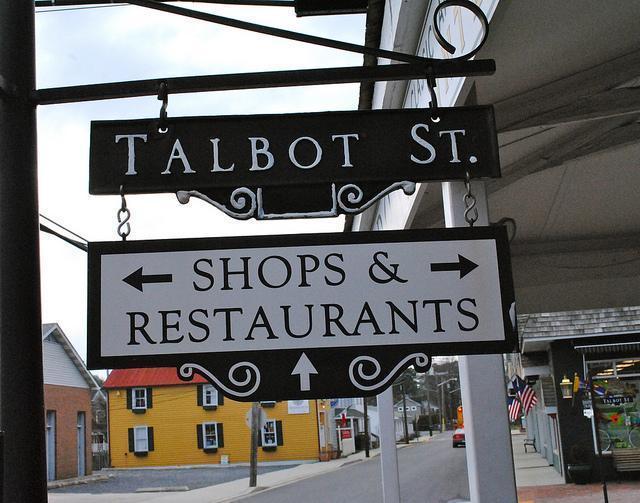How many bedrooms are for rent?
Give a very brief answer. 0. 